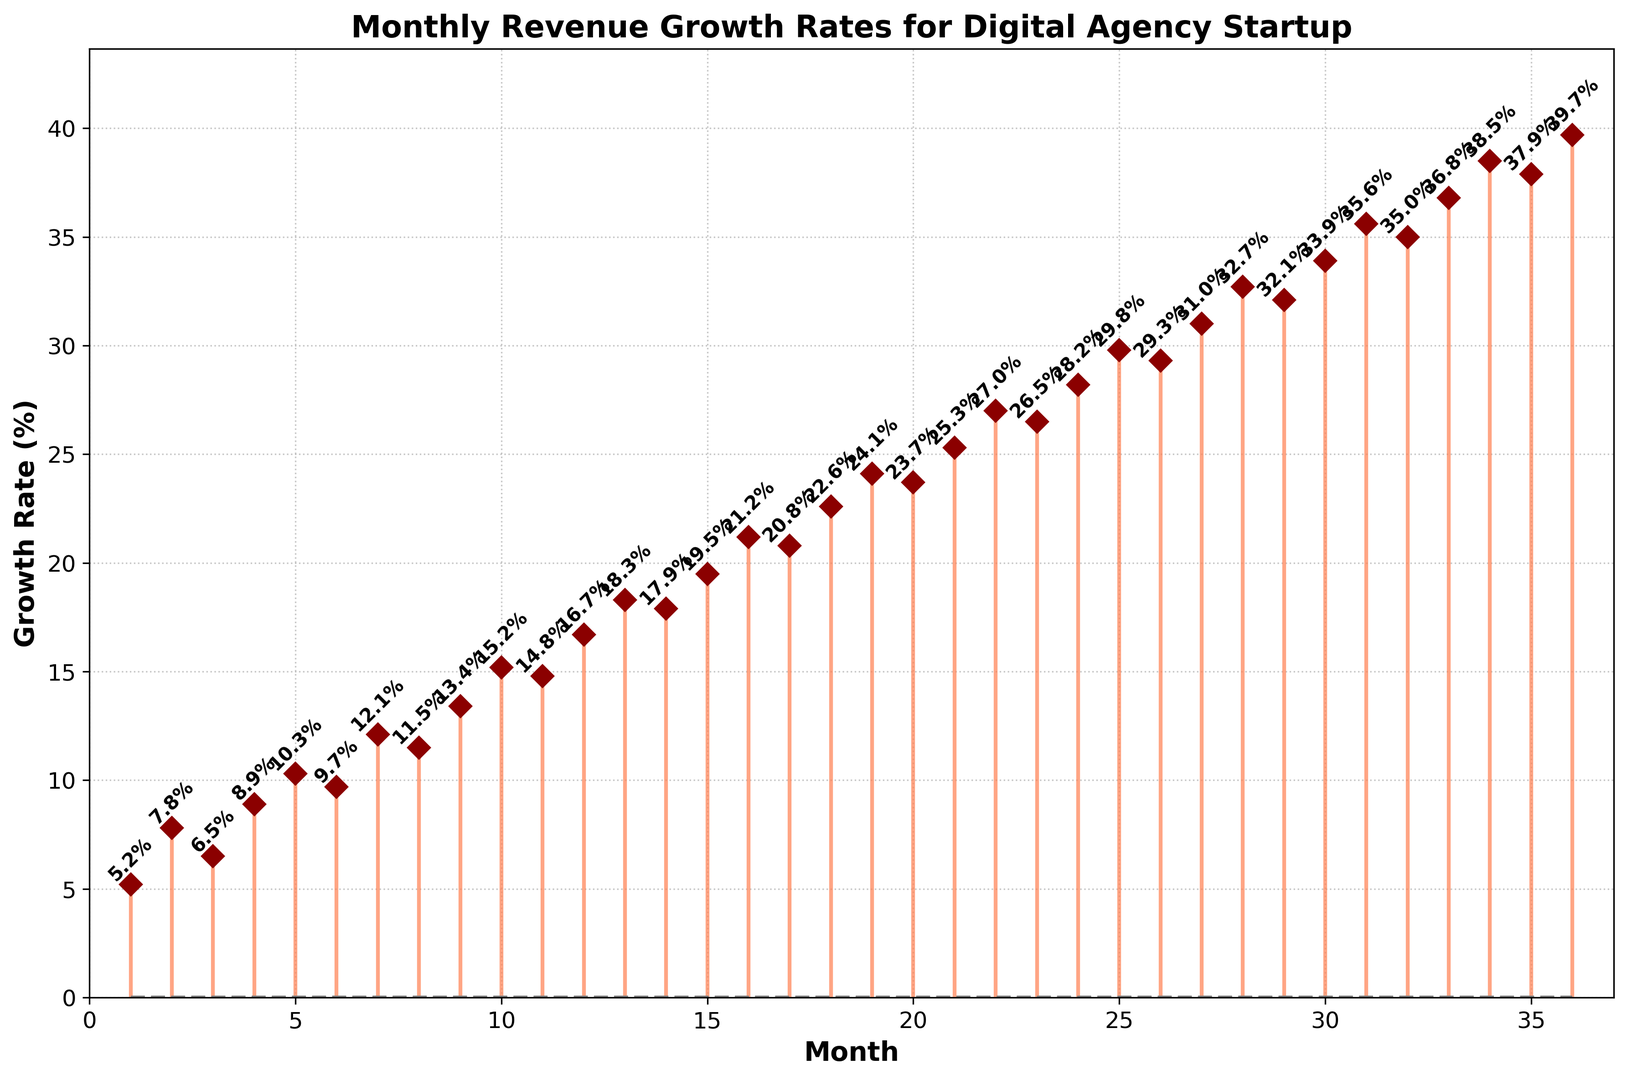what is the growth rate in the 10th month? The 10th month corresponds to a specific x-axis value. The corresponding y-axis value for the 10th month is 15.2%.
Answer: 15.2% Comparing the 6th and 12th months, which one had a higher growth rate? To compare the growth rates for the 6th and 12th months, look at the y-axis values for these months. In the 6th month, the growth rate is 9.7%, while in the 12th month, it is 16.7%. Therefore, the 12th month had a higher growth rate.
Answer: 12th month What is the average growth rate for the first year (the first 12 months)? To find the average growth rate for the first 12 months, sum up the growth rates for months 1 through 12 and divide by 12. The sum is (5.2 + 7.8 + 6.5 + 8.9 + 10.3 + 9.7 + 12.1 + 11.5 + 13.4 + 15.2 + 14.8 + 16.7) = 132.1. Therefore, the average is 132.1 / 12 = 11.01%.
Answer: 11.01% Which months experienced a negative growth rate? The graph does not show any negative values for the growth rates. All displayed values are positive.
Answer: None Which month experienced the highest growth rate in the second year (months 13-24)? To identify the month with the highest growth rate in the second year, look for the maximum y-axis value between months 13 to 24. The highest growth rate in this period is in the 24th month with a value of 28.2%.
Answer: 24th month What is the difference in growth rates between months 1 and 36? To find the difference, subtract the growth rate of the 1st month (5.2%) from the growth rate of the 36th month (39.7%). So, 39.7% - 5.2% = 34.5%.
Answer: 34.5% How many months have growth rates above 20%? To count the number of months with growth rates above 20%, look at the y-axis values. These months are: 18, 19, 20, 21, 22, 23, 24, 25, 26, 27, 28, 29, 30, 31, 32, 33, 34, 35, and 36. Therefore, there are 19 months with growth rates above 20%.
Answer: 19 